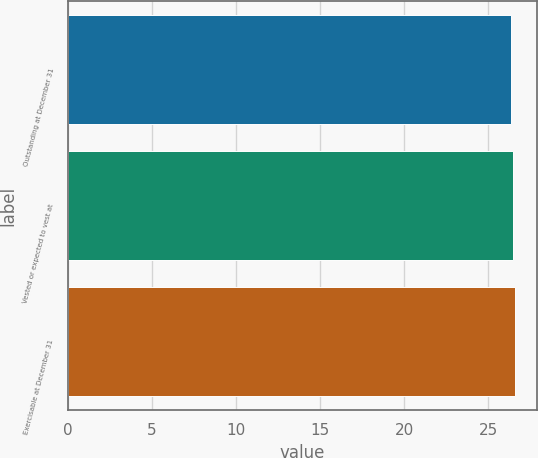Convert chart to OTSL. <chart><loc_0><loc_0><loc_500><loc_500><bar_chart><fcel>Outstanding at December 31<fcel>Vested or expected to vest at<fcel>Exercisable at December 31<nl><fcel>26.39<fcel>26.49<fcel>26.59<nl></chart> 